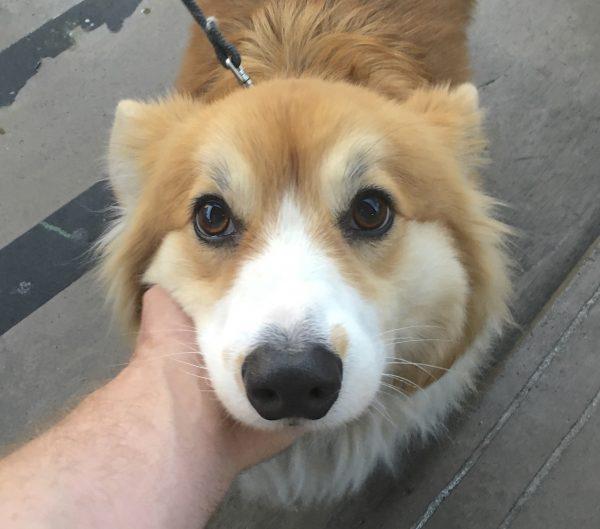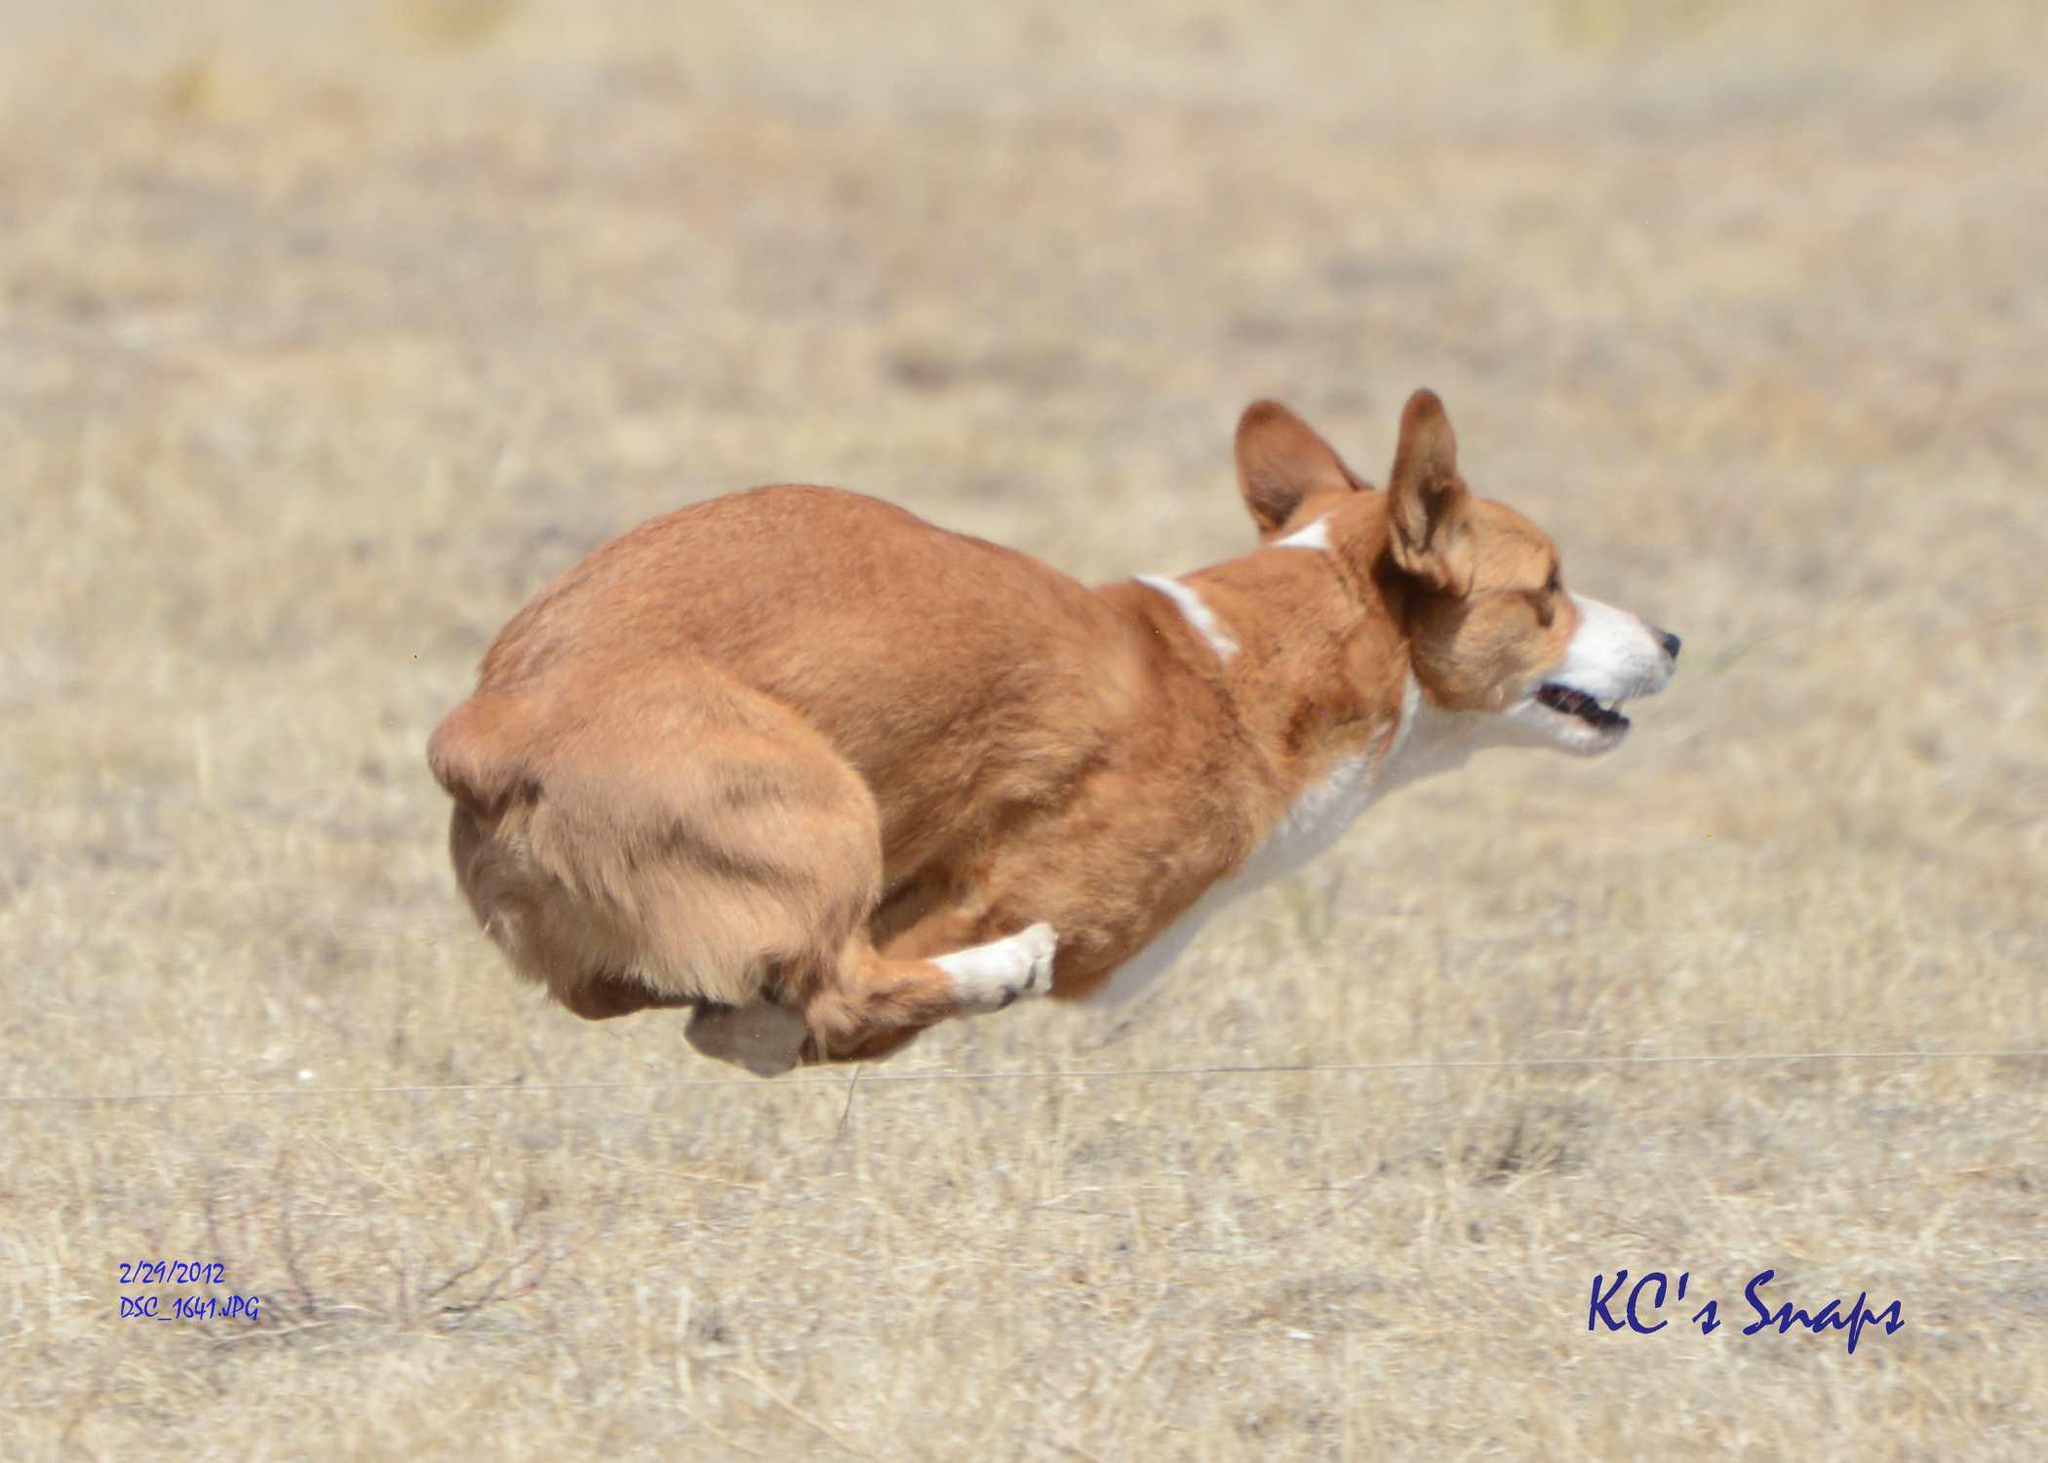The first image is the image on the left, the second image is the image on the right. For the images shown, is this caption "The dog in the left photo has a star shapped tag hanging from its collar." true? Answer yes or no. No. The first image is the image on the left, the second image is the image on the right. For the images displayed, is the sentence "One image features a dog wearing a collar with a star-shaped tag." factually correct? Answer yes or no. No. 